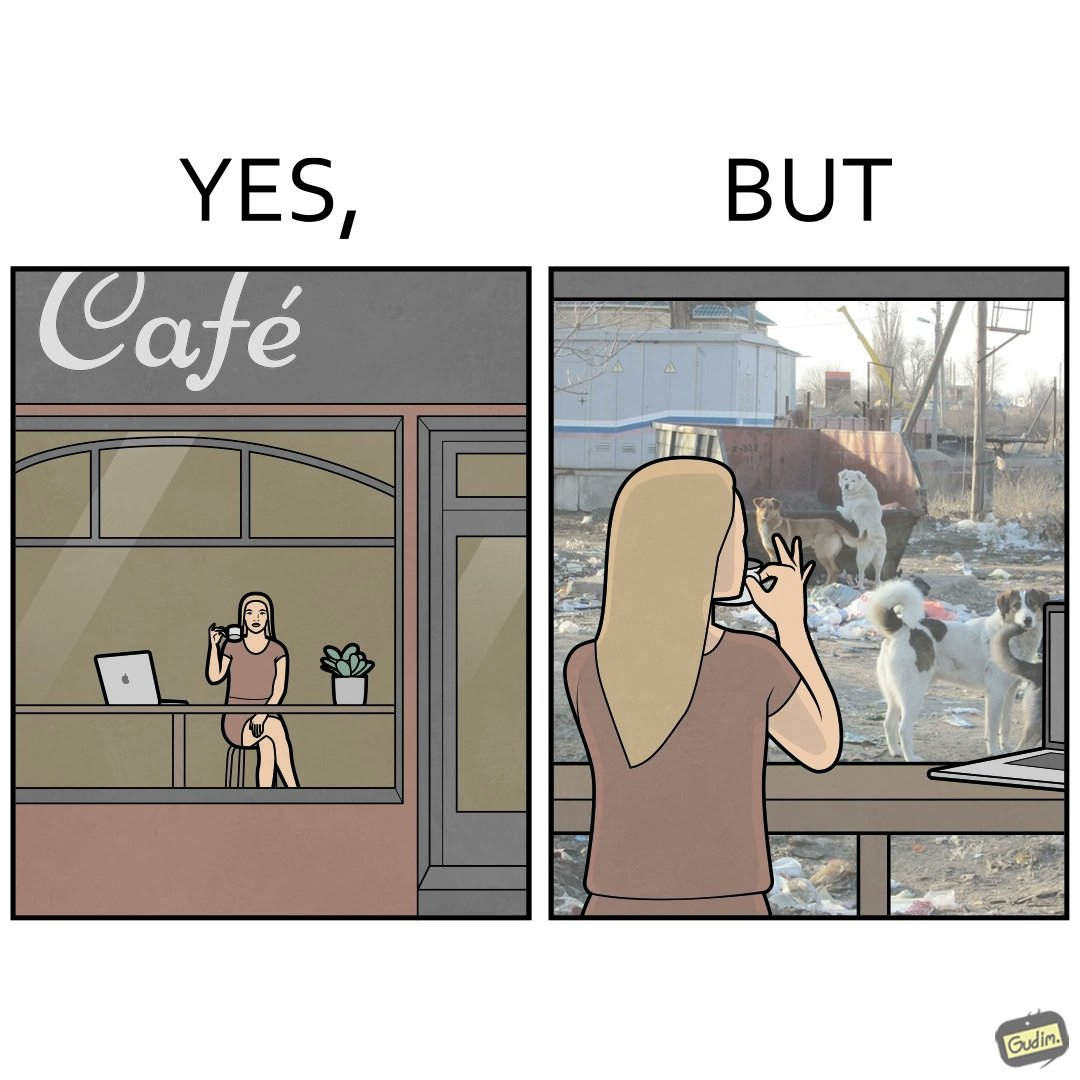Is there satirical content in this image? Yes, this image is satirical. 